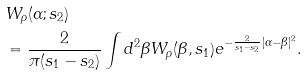Convert formula to latex. <formula><loc_0><loc_0><loc_500><loc_500>& W _ { \rho } ( \alpha ; s _ { 2 } ) \\ & = \frac { 2 } { \pi ( s _ { 1 } - s _ { 2 } ) } \int d ^ { 2 } \beta W _ { \rho } ( \beta , s _ { 1 } ) e ^ { - \frac { 2 } { s _ { 1 } - s _ { 2 } } | \alpha - \beta | ^ { 2 } } .</formula> 